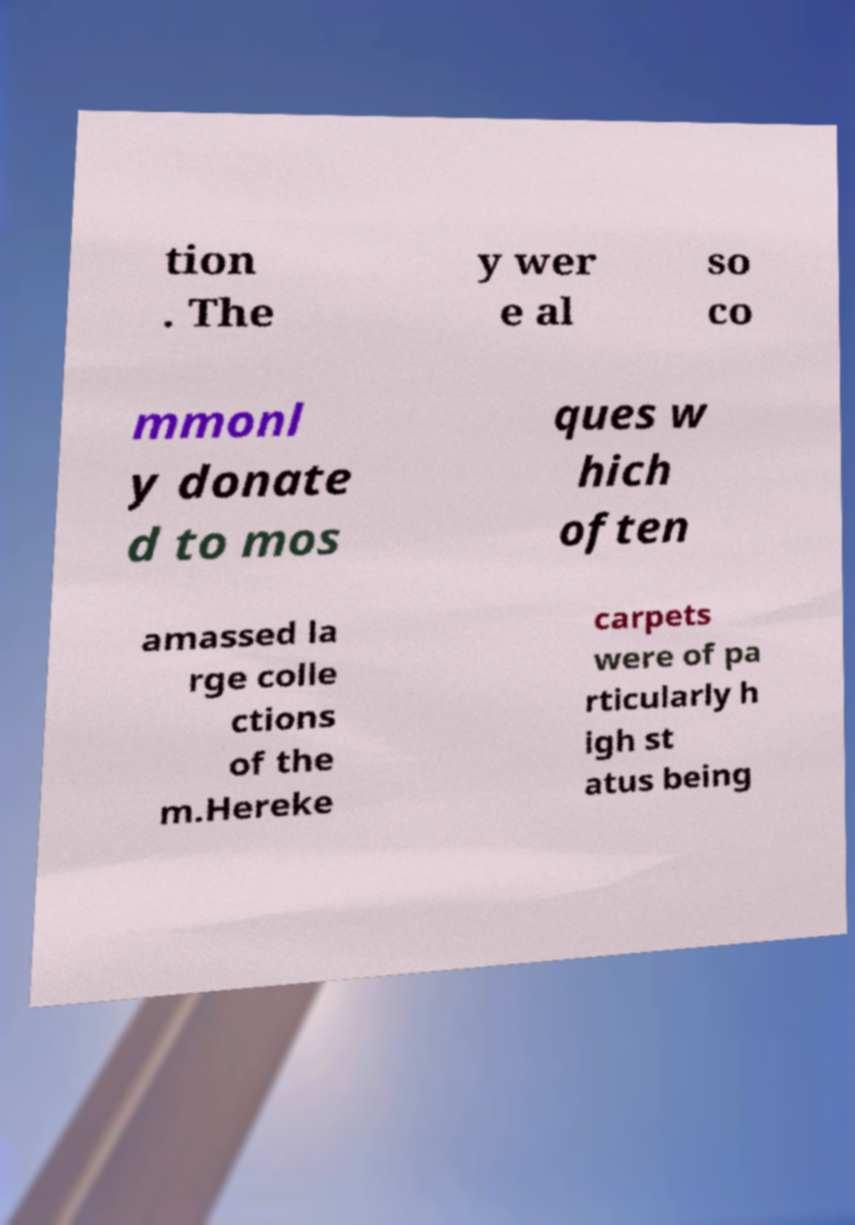Could you assist in decoding the text presented in this image and type it out clearly? tion . The y wer e al so co mmonl y donate d to mos ques w hich often amassed la rge colle ctions of the m.Hereke carpets were of pa rticularly h igh st atus being 